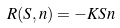<formula> <loc_0><loc_0><loc_500><loc_500>R ( S , n ) = - K S n</formula> 